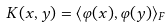Convert formula to latex. <formula><loc_0><loc_0><loc_500><loc_500>K ( x , y ) = \langle \varphi ( x ) , \varphi ( y ) \rangle _ { F }</formula> 